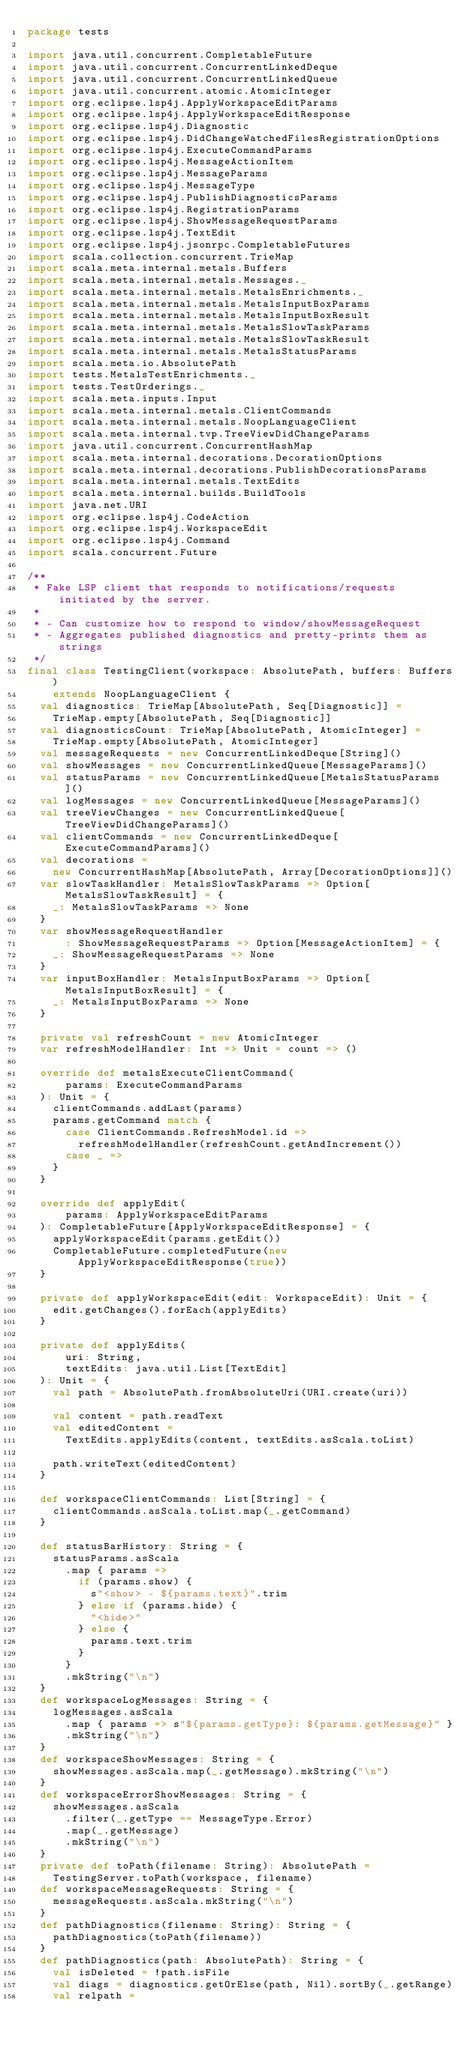Convert code to text. <code><loc_0><loc_0><loc_500><loc_500><_Scala_>package tests

import java.util.concurrent.CompletableFuture
import java.util.concurrent.ConcurrentLinkedDeque
import java.util.concurrent.ConcurrentLinkedQueue
import java.util.concurrent.atomic.AtomicInteger
import org.eclipse.lsp4j.ApplyWorkspaceEditParams
import org.eclipse.lsp4j.ApplyWorkspaceEditResponse
import org.eclipse.lsp4j.Diagnostic
import org.eclipse.lsp4j.DidChangeWatchedFilesRegistrationOptions
import org.eclipse.lsp4j.ExecuteCommandParams
import org.eclipse.lsp4j.MessageActionItem
import org.eclipse.lsp4j.MessageParams
import org.eclipse.lsp4j.MessageType
import org.eclipse.lsp4j.PublishDiagnosticsParams
import org.eclipse.lsp4j.RegistrationParams
import org.eclipse.lsp4j.ShowMessageRequestParams
import org.eclipse.lsp4j.TextEdit
import org.eclipse.lsp4j.jsonrpc.CompletableFutures
import scala.collection.concurrent.TrieMap
import scala.meta.internal.metals.Buffers
import scala.meta.internal.metals.Messages._
import scala.meta.internal.metals.MetalsEnrichments._
import scala.meta.internal.metals.MetalsInputBoxParams
import scala.meta.internal.metals.MetalsInputBoxResult
import scala.meta.internal.metals.MetalsSlowTaskParams
import scala.meta.internal.metals.MetalsSlowTaskResult
import scala.meta.internal.metals.MetalsStatusParams
import scala.meta.io.AbsolutePath
import tests.MetalsTestEnrichments._
import tests.TestOrderings._
import scala.meta.inputs.Input
import scala.meta.internal.metals.ClientCommands
import scala.meta.internal.metals.NoopLanguageClient
import scala.meta.internal.tvp.TreeViewDidChangeParams
import java.util.concurrent.ConcurrentHashMap
import scala.meta.internal.decorations.DecorationOptions
import scala.meta.internal.decorations.PublishDecorationsParams
import scala.meta.internal.metals.TextEdits
import scala.meta.internal.builds.BuildTools
import java.net.URI
import org.eclipse.lsp4j.CodeAction
import org.eclipse.lsp4j.WorkspaceEdit
import org.eclipse.lsp4j.Command
import scala.concurrent.Future

/**
 * Fake LSP client that responds to notifications/requests initiated by the server.
 *
 * - Can customize how to respond to window/showMessageRequest
 * - Aggregates published diagnostics and pretty-prints them as strings
 */
final class TestingClient(workspace: AbsolutePath, buffers: Buffers)
    extends NoopLanguageClient {
  val diagnostics: TrieMap[AbsolutePath, Seq[Diagnostic]] =
    TrieMap.empty[AbsolutePath, Seq[Diagnostic]]
  val diagnosticsCount: TrieMap[AbsolutePath, AtomicInteger] =
    TrieMap.empty[AbsolutePath, AtomicInteger]
  val messageRequests = new ConcurrentLinkedDeque[String]()
  val showMessages = new ConcurrentLinkedQueue[MessageParams]()
  val statusParams = new ConcurrentLinkedQueue[MetalsStatusParams]()
  val logMessages = new ConcurrentLinkedQueue[MessageParams]()
  val treeViewChanges = new ConcurrentLinkedQueue[TreeViewDidChangeParams]()
  val clientCommands = new ConcurrentLinkedDeque[ExecuteCommandParams]()
  val decorations =
    new ConcurrentHashMap[AbsolutePath, Array[DecorationOptions]]()
  var slowTaskHandler: MetalsSlowTaskParams => Option[MetalsSlowTaskResult] = {
    _: MetalsSlowTaskParams => None
  }
  var showMessageRequestHandler
      : ShowMessageRequestParams => Option[MessageActionItem] = {
    _: ShowMessageRequestParams => None
  }
  var inputBoxHandler: MetalsInputBoxParams => Option[MetalsInputBoxResult] = {
    _: MetalsInputBoxParams => None
  }

  private val refreshCount = new AtomicInteger
  var refreshModelHandler: Int => Unit = count => ()

  override def metalsExecuteClientCommand(
      params: ExecuteCommandParams
  ): Unit = {
    clientCommands.addLast(params)
    params.getCommand match {
      case ClientCommands.RefreshModel.id =>
        refreshModelHandler(refreshCount.getAndIncrement())
      case _ =>
    }
  }

  override def applyEdit(
      params: ApplyWorkspaceEditParams
  ): CompletableFuture[ApplyWorkspaceEditResponse] = {
    applyWorkspaceEdit(params.getEdit())
    CompletableFuture.completedFuture(new ApplyWorkspaceEditResponse(true))
  }

  private def applyWorkspaceEdit(edit: WorkspaceEdit): Unit = {
    edit.getChanges().forEach(applyEdits)
  }

  private def applyEdits(
      uri: String,
      textEdits: java.util.List[TextEdit]
  ): Unit = {
    val path = AbsolutePath.fromAbsoluteUri(URI.create(uri))

    val content = path.readText
    val editedContent =
      TextEdits.applyEdits(content, textEdits.asScala.toList)

    path.writeText(editedContent)
  }

  def workspaceClientCommands: List[String] = {
    clientCommands.asScala.toList.map(_.getCommand)
  }

  def statusBarHistory: String = {
    statusParams.asScala
      .map { params =>
        if (params.show) {
          s"<show> - ${params.text}".trim
        } else if (params.hide) {
          "<hide>"
        } else {
          params.text.trim
        }
      }
      .mkString("\n")
  }
  def workspaceLogMessages: String = {
    logMessages.asScala
      .map { params => s"${params.getType}: ${params.getMessage}" }
      .mkString("\n")
  }
  def workspaceShowMessages: String = {
    showMessages.asScala.map(_.getMessage).mkString("\n")
  }
  def workspaceErrorShowMessages: String = {
    showMessages.asScala
      .filter(_.getType == MessageType.Error)
      .map(_.getMessage)
      .mkString("\n")
  }
  private def toPath(filename: String): AbsolutePath =
    TestingServer.toPath(workspace, filename)
  def workspaceMessageRequests: String = {
    messageRequests.asScala.mkString("\n")
  }
  def pathDiagnostics(filename: String): String = {
    pathDiagnostics(toPath(filename))
  }
  def pathDiagnostics(path: AbsolutePath): String = {
    val isDeleted = !path.isFile
    val diags = diagnostics.getOrElse(path, Nil).sortBy(_.getRange)
    val relpath =</code> 